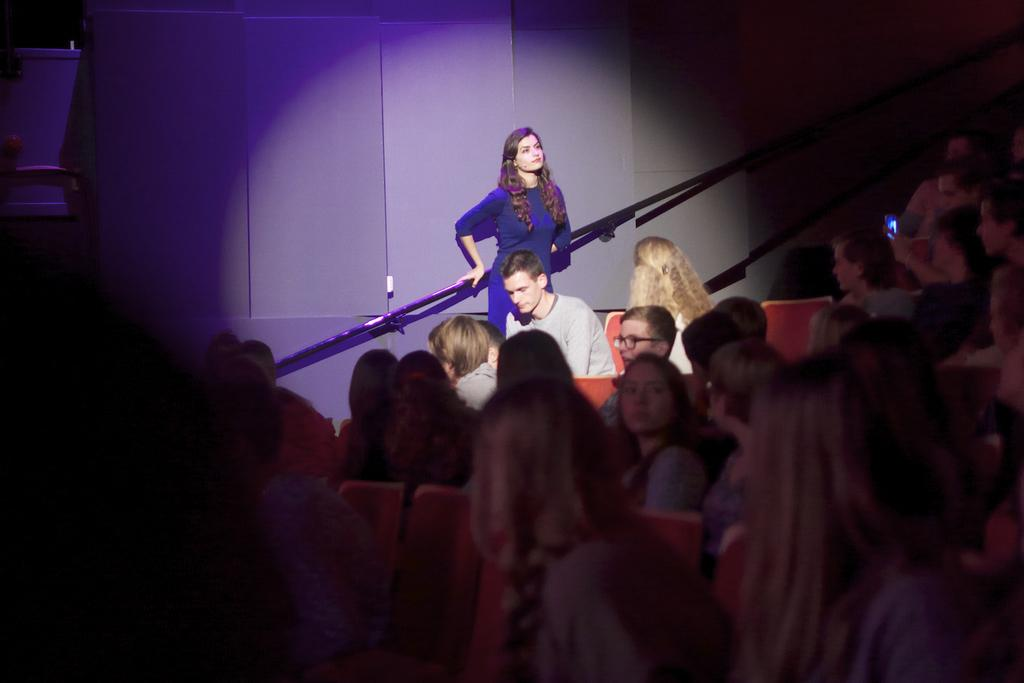What is happening in the image involving a group of people? There is a group of people sitting on chairs in the image. Can you describe the position of the person in the background? There is a person standing in the background of the image. What is the purpose of the focus light in the image? The focus light is on the person who is standing in the background. What type of drain can be seen in the image? There is no drain present in the image. What kind of bushes are visible in the background of the image? There are no bushes visible in the background of the image. 